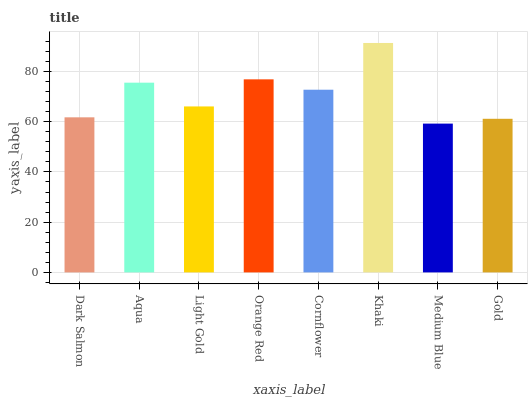Is Medium Blue the minimum?
Answer yes or no. Yes. Is Khaki the maximum?
Answer yes or no. Yes. Is Aqua the minimum?
Answer yes or no. No. Is Aqua the maximum?
Answer yes or no. No. Is Aqua greater than Dark Salmon?
Answer yes or no. Yes. Is Dark Salmon less than Aqua?
Answer yes or no. Yes. Is Dark Salmon greater than Aqua?
Answer yes or no. No. Is Aqua less than Dark Salmon?
Answer yes or no. No. Is Cornflower the high median?
Answer yes or no. Yes. Is Light Gold the low median?
Answer yes or no. Yes. Is Medium Blue the high median?
Answer yes or no. No. Is Khaki the low median?
Answer yes or no. No. 